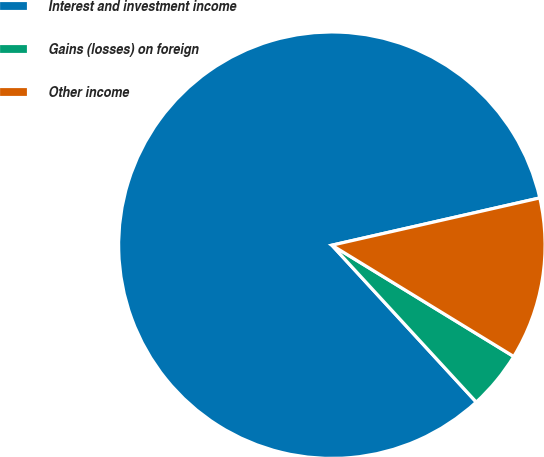Convert chart to OTSL. <chart><loc_0><loc_0><loc_500><loc_500><pie_chart><fcel>Interest and investment income<fcel>Gains (losses) on foreign<fcel>Other income<nl><fcel>83.28%<fcel>4.42%<fcel>12.3%<nl></chart> 